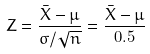<formula> <loc_0><loc_0><loc_500><loc_500>Z = { \frac { { \bar { X } } - \mu } { \sigma / { \sqrt { n } } } } = { \frac { { \bar { X } } - \mu } { 0 . 5 } }</formula> 